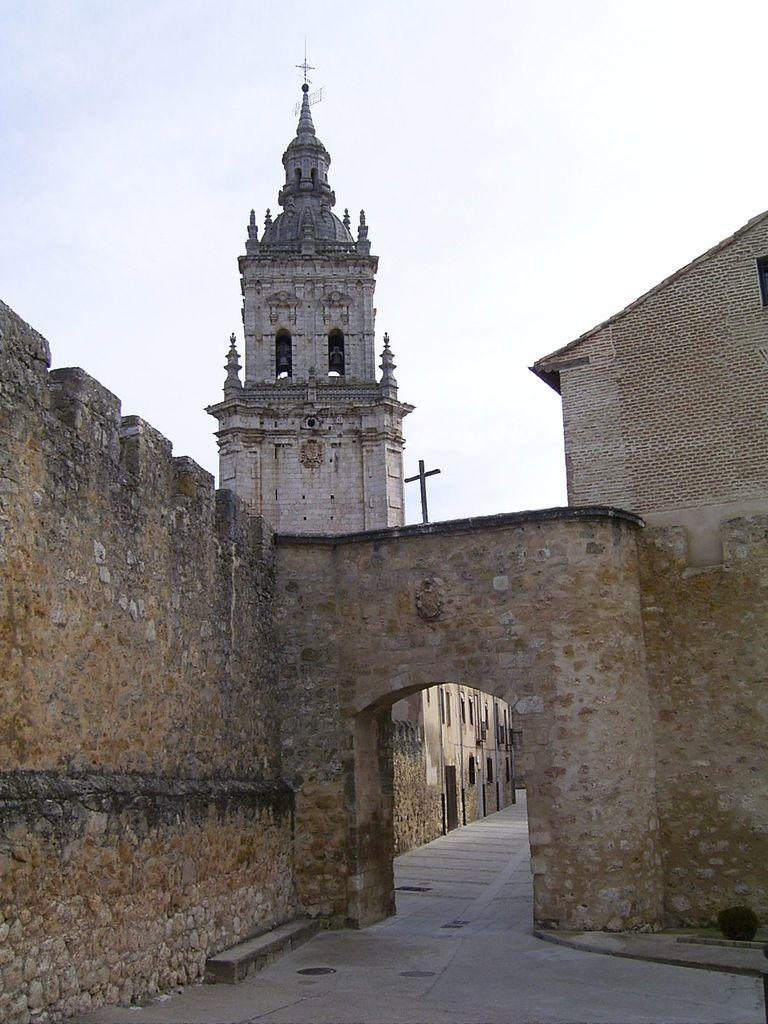What is the main structure in the center of the image? There is an arch in the center of the image. What can be seen on either side of the arch? There are walls on the right and left sides of the image. What type of building can be seen in the background? There is a church in the background of the image. How many tables are visible in the image? There are no tables present in the image. What is the governor doing in the image? There is no governor present in the image. 